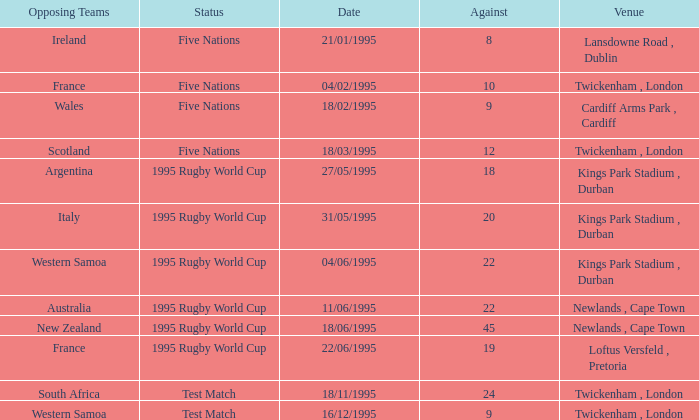What's the total against for opposing team scotland at twickenham, london venue with a status of five nations? 1.0. Would you be able to parse every entry in this table? {'header': ['Opposing Teams', 'Status', 'Date', 'Against', 'Venue'], 'rows': [['Ireland', 'Five Nations', '21/01/1995', '8', 'Lansdowne Road , Dublin'], ['France', 'Five Nations', '04/02/1995', '10', 'Twickenham , London'], ['Wales', 'Five Nations', '18/02/1995', '9', 'Cardiff Arms Park , Cardiff'], ['Scotland', 'Five Nations', '18/03/1995', '12', 'Twickenham , London'], ['Argentina', '1995 Rugby World Cup', '27/05/1995', '18', 'Kings Park Stadium , Durban'], ['Italy', '1995 Rugby World Cup', '31/05/1995', '20', 'Kings Park Stadium , Durban'], ['Western Samoa', '1995 Rugby World Cup', '04/06/1995', '22', 'Kings Park Stadium , Durban'], ['Australia', '1995 Rugby World Cup', '11/06/1995', '22', 'Newlands , Cape Town'], ['New Zealand', '1995 Rugby World Cup', '18/06/1995', '45', 'Newlands , Cape Town'], ['France', '1995 Rugby World Cup', '22/06/1995', '19', 'Loftus Versfeld , Pretoria'], ['South Africa', 'Test Match', '18/11/1995', '24', 'Twickenham , London'], ['Western Samoa', 'Test Match', '16/12/1995', '9', 'Twickenham , London']]} 